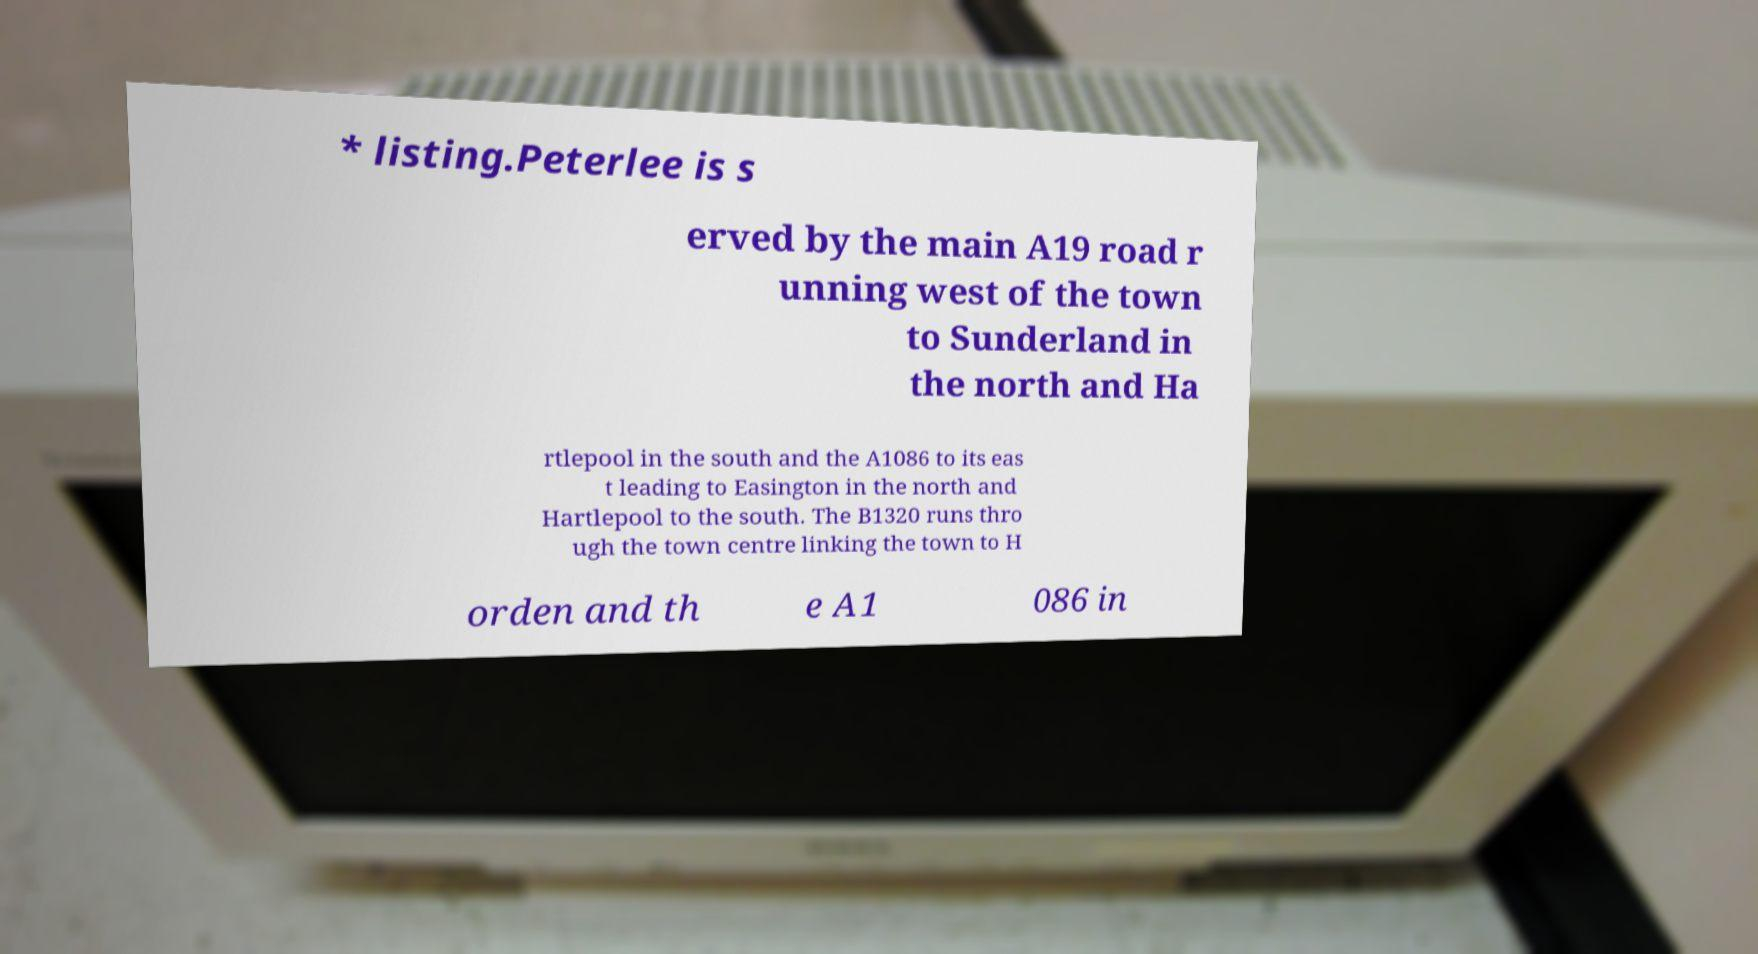I need the written content from this picture converted into text. Can you do that? * listing.Peterlee is s erved by the main A19 road r unning west of the town to Sunderland in the north and Ha rtlepool in the south and the A1086 to its eas t leading to Easington in the north and Hartlepool to the south. The B1320 runs thro ugh the town centre linking the town to H orden and th e A1 086 in 